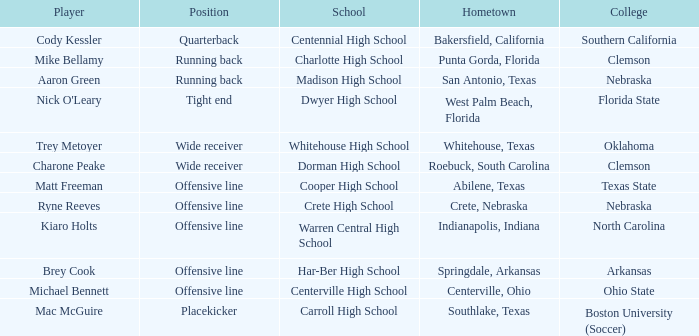What college did the placekicker go to? Boston University (Soccer). 